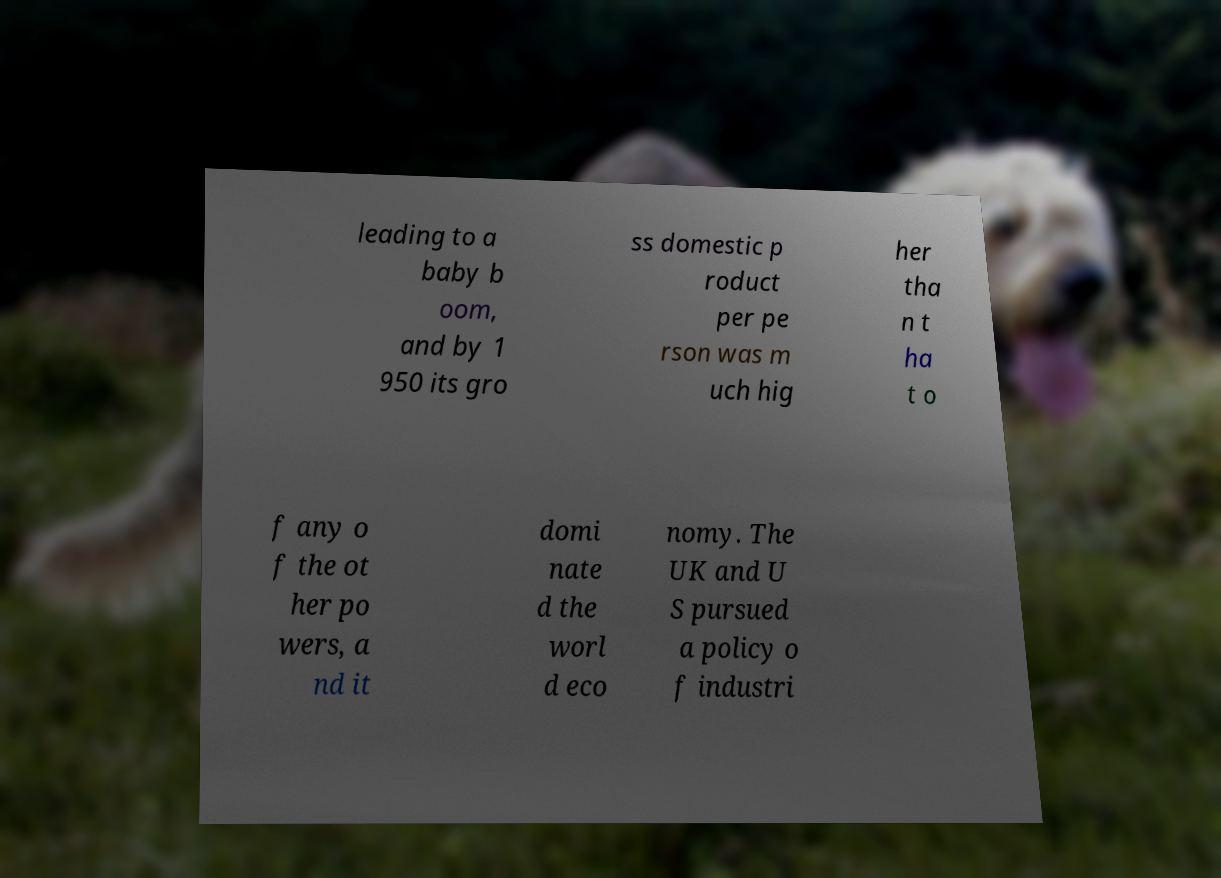Please identify and transcribe the text found in this image. leading to a baby b oom, and by 1 950 its gro ss domestic p roduct per pe rson was m uch hig her tha n t ha t o f any o f the ot her po wers, a nd it domi nate d the worl d eco nomy. The UK and U S pursued a policy o f industri 